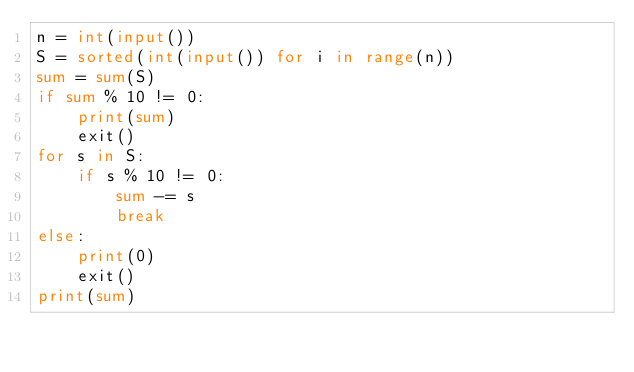<code> <loc_0><loc_0><loc_500><loc_500><_Python_>n = int(input())
S = sorted(int(input()) for i in range(n))
sum = sum(S)
if sum % 10 != 0:
    print(sum)
    exit()
for s in S:
    if s % 10 != 0:
        sum -= s
        break
else:
    print(0)
    exit()
print(sum)</code> 